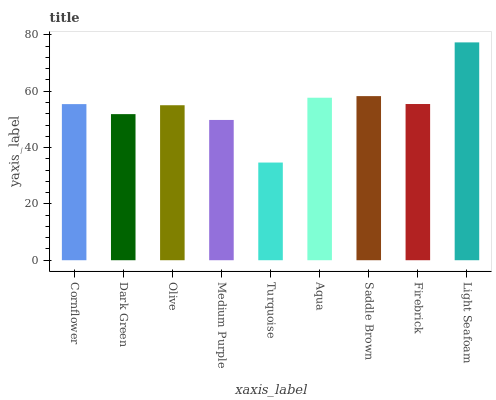Is Turquoise the minimum?
Answer yes or no. Yes. Is Light Seafoam the maximum?
Answer yes or no. Yes. Is Dark Green the minimum?
Answer yes or no. No. Is Dark Green the maximum?
Answer yes or no. No. Is Cornflower greater than Dark Green?
Answer yes or no. Yes. Is Dark Green less than Cornflower?
Answer yes or no. Yes. Is Dark Green greater than Cornflower?
Answer yes or no. No. Is Cornflower less than Dark Green?
Answer yes or no. No. Is Cornflower the high median?
Answer yes or no. Yes. Is Cornflower the low median?
Answer yes or no. Yes. Is Light Seafoam the high median?
Answer yes or no. No. Is Dark Green the low median?
Answer yes or no. No. 